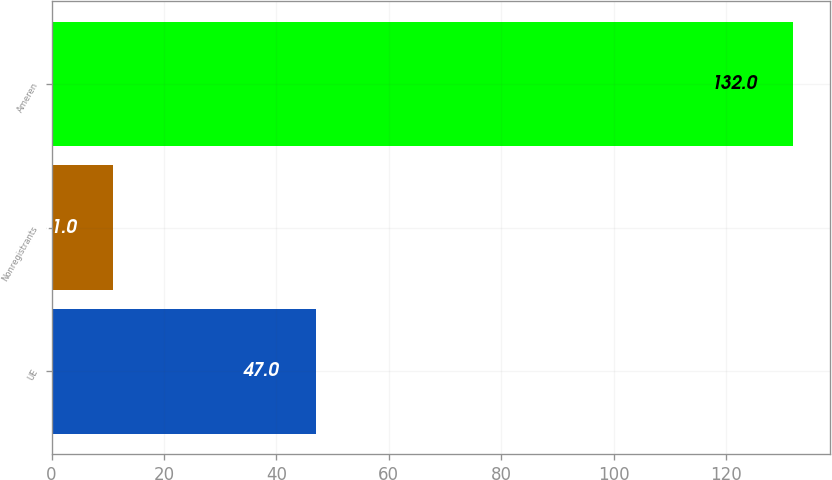Convert chart. <chart><loc_0><loc_0><loc_500><loc_500><bar_chart><fcel>UE<fcel>Nonregistrants<fcel>Ameren<nl><fcel>47<fcel>11<fcel>132<nl></chart> 